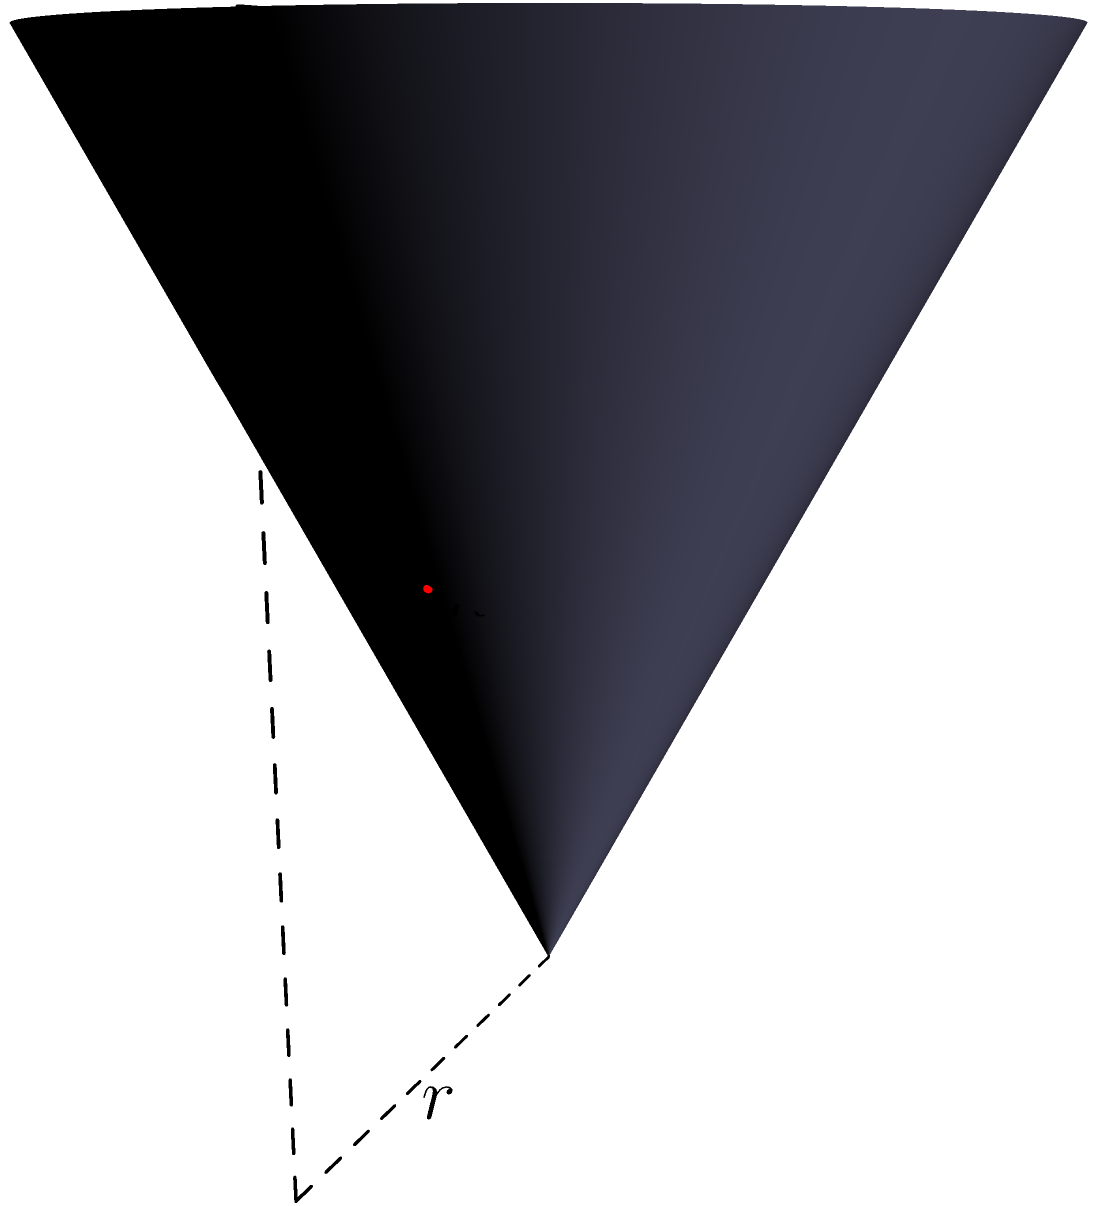In light of recent data privacy concerns, consider a cone-shaped data storage device with height $h$ and base radius $r$. If a cross-section is taken at half the height of the cone, what is the ratio of the cross-sectional area at this point to the base area of the cone? Let's approach this step-by-step:

1) In a cone, the radius at any height is proportional to the height from the apex. We can express this relationship as:

   $$\frac{r_1}{r} = \frac{h-h_1}{h}$$

   where $r_1$ is the radius at height $h_1$ from the base.

2) We're asked about the cross-section at half the height, so $h_1 = h/2$. Substituting this:

   $$\frac{r_1}{r} = \frac{h-h/2}{h} = \frac{h/2}{h} = \frac{1}{2}$$

3) This means $r_1 = r/2$.

4) The area of a circle is proportional to the square of its radius. The ratio of the areas will be:

   $$\frac{A_1}{A} = \frac{\pi r_1^2}{\pi r^2} = \frac{r_1^2}{r^2} = (\frac{1}{2})^2 = \frac{1}{4}$$

5) Therefore, the cross-sectional area at half the height is 1/4 of the base area.

This geometric relationship could be analogous to how data might be distributed or accessed within the storage device, which could have implications for data privacy and security.
Answer: 1:4 